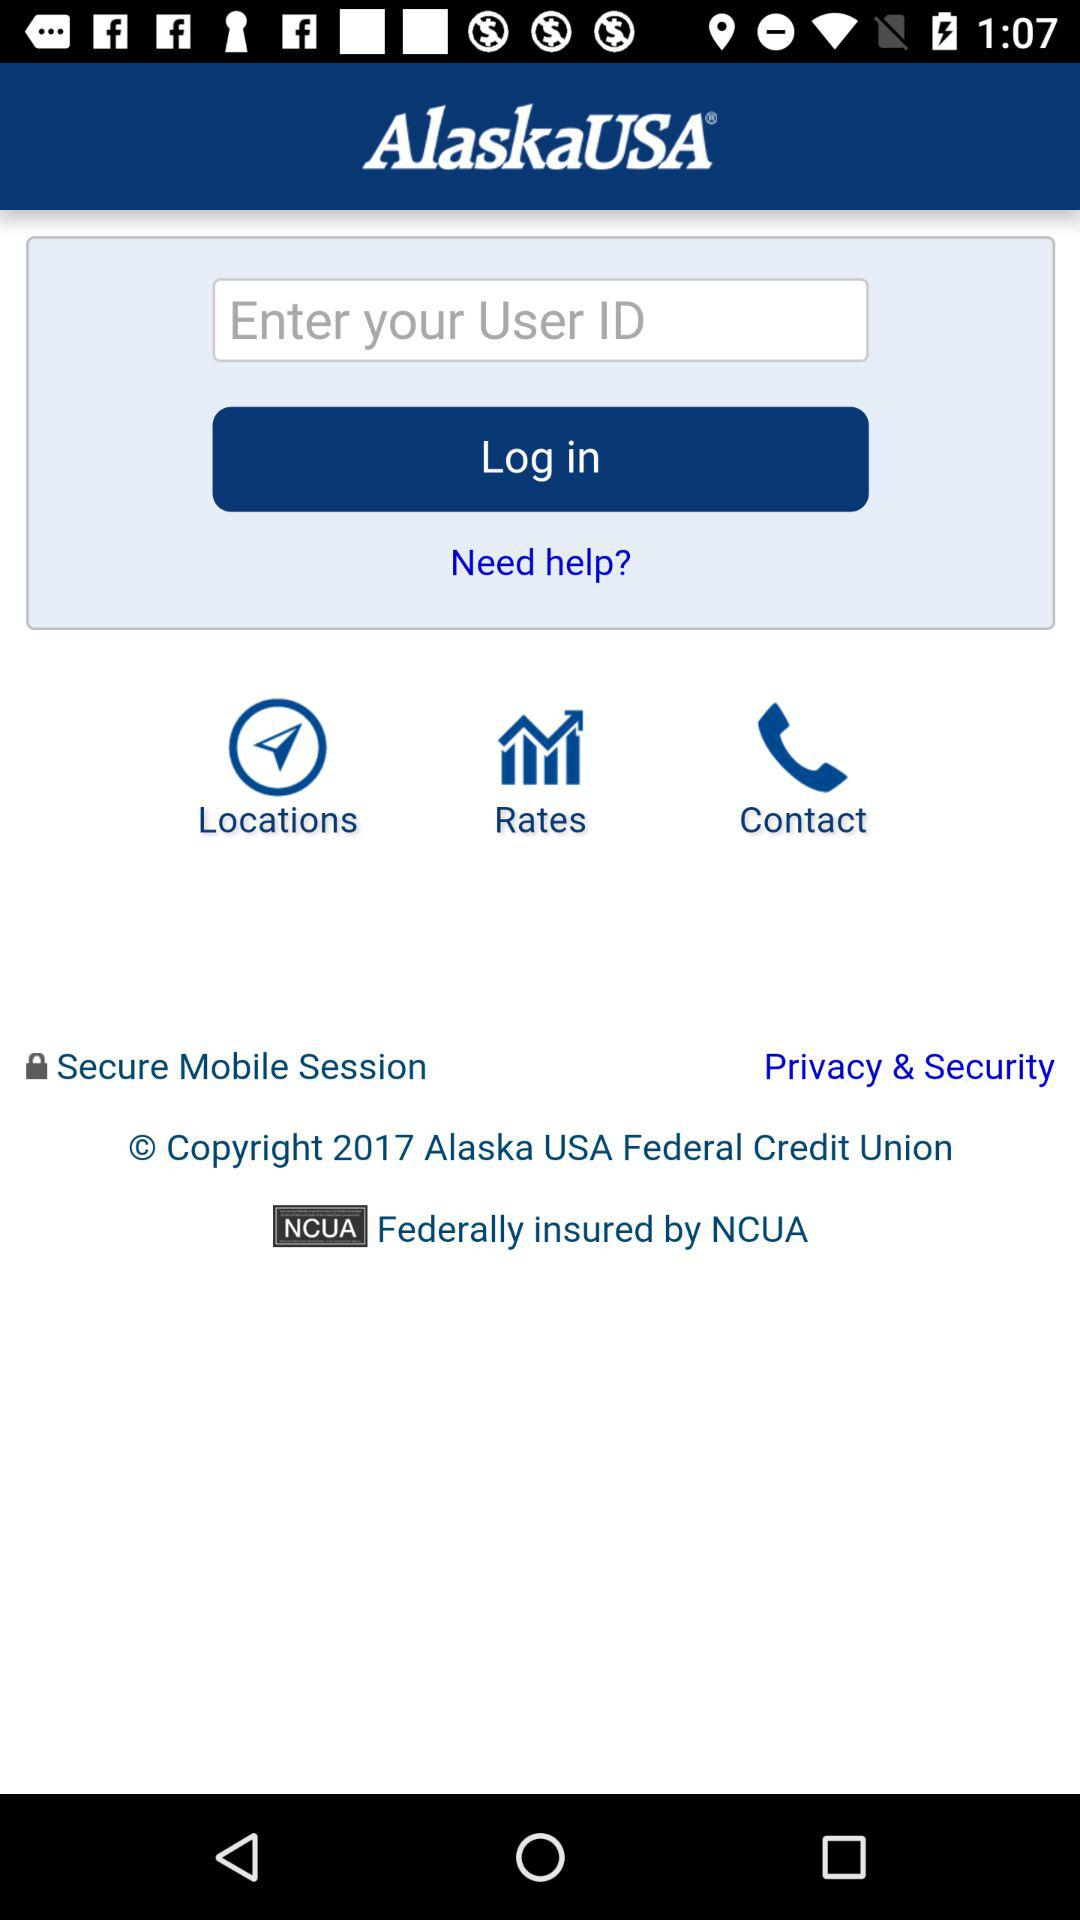What is the name of the application? The name of the application is "AlaskaUSA". 